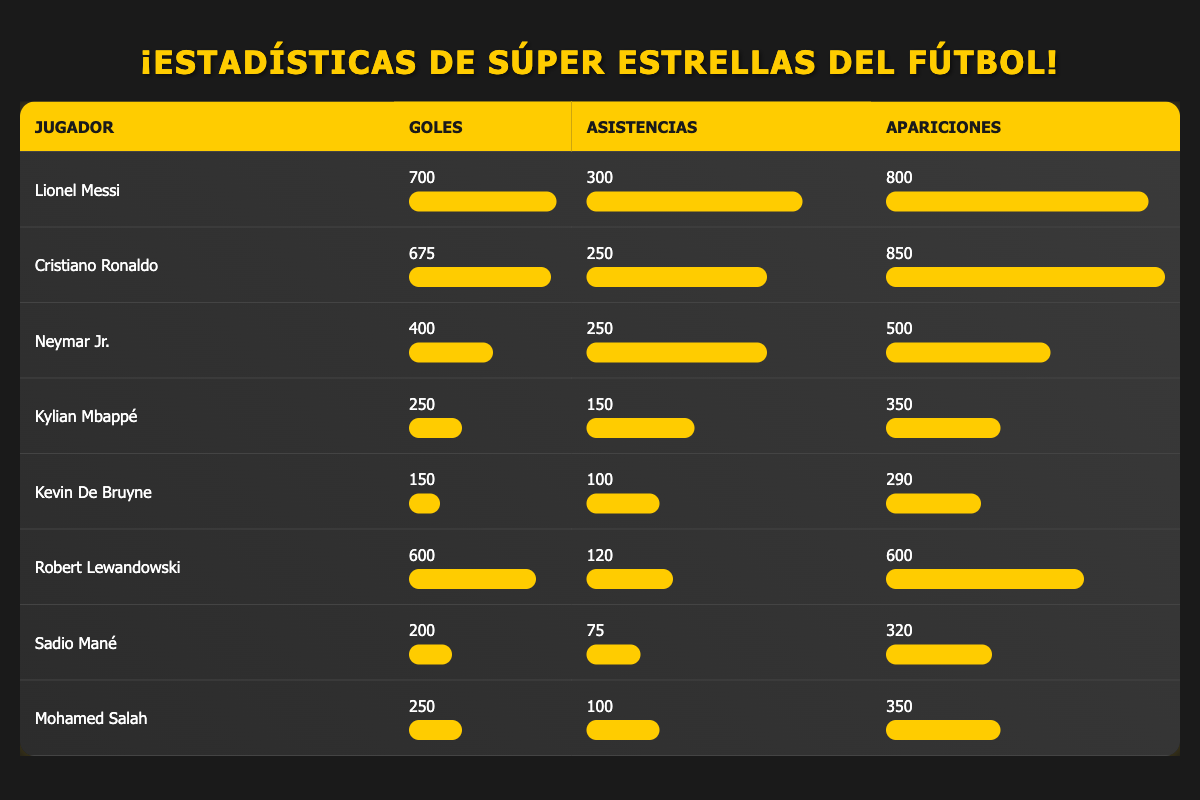What is the total number of goals scored by Lionel Messi and Cristiano Ronaldo combined? To find the total goals scored by Messi and Ronaldo, we add their goals together: Messi scored 700 goals and Ronaldo scored 675 goals. Thus, the total is 700 + 675 = 1375.
Answer: 1375 Who has more assists, Neymar Jr. or Kevin De Bruyne? Neymar Jr. has 250 assists, while Kevin De Bruyne has 100 assists. Comparing the two, it's clear that Neymar has more assists than De Bruyne.
Answer: Yes What is the average number of goals scored by the players in the table? To calculate the average goals, we sum all the goals scored by the players: 700 + 675 + 400 + 250 + 150 + 600 + 200 + 250 = 3125. There are 8 players, so the average is 3125 / 8 = 390.625.
Answer: 390.625 Is Sadio Mané's number of appearances greater than Robert Lewandowski's? Sadio Mané has 320 appearances, while Robert Lewandowski has 600 appearances. Since 320 is less than 600, the statement is false.
Answer: No Which player contributed more assists per appearance, Neymar Jr. or Kylian Mbappé? To find the assists per appearance, we divide the assists by the appearances for both players. Neymar: 250 assists / 500 appearances = 0.5; Mbappé: 150 assists / 350 appearances = 0.428. Since 0.5 is greater than 0.428, Neymar contributed more assists per appearance.
Answer: Neymar Jr What is the total number of appearances for all players in the table? We sum the appearances of all players: 800 + 850 + 500 + 350 + 290 + 600 + 320 + 350 = 4090. Therefore, the total number of appearances is 4090.
Answer: 4090 Did any player score less than 200 goals, and if so, who? We look at the goals scored by each player. Kylian Mbappé (250), Kevin De Bruyne (150), Sadio Mané (200). The only player who scored less than 200 goals is Kevin De Bruyne, who scored 150 goals.
Answer: Yes, Kevin De Bruyne Who scored the maximum goals among the players? From the table, we identify the player with the most goals scored. Lionel Messi scored the highest with 700 goals.
Answer: Lionel Messi 